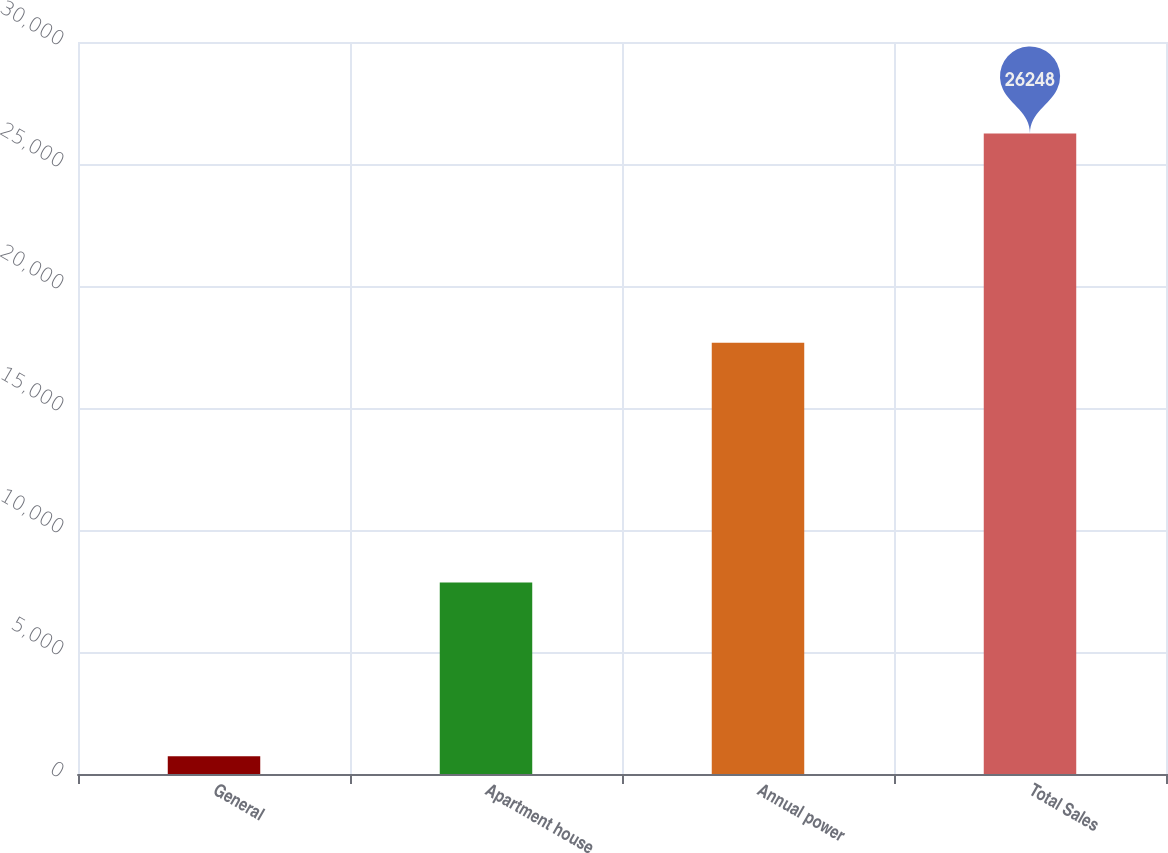Convert chart. <chart><loc_0><loc_0><loc_500><loc_500><bar_chart><fcel>General<fcel>Apartment house<fcel>Annual power<fcel>Total Sales<nl><fcel>729<fcel>7845<fcel>17674<fcel>26248<nl></chart> 